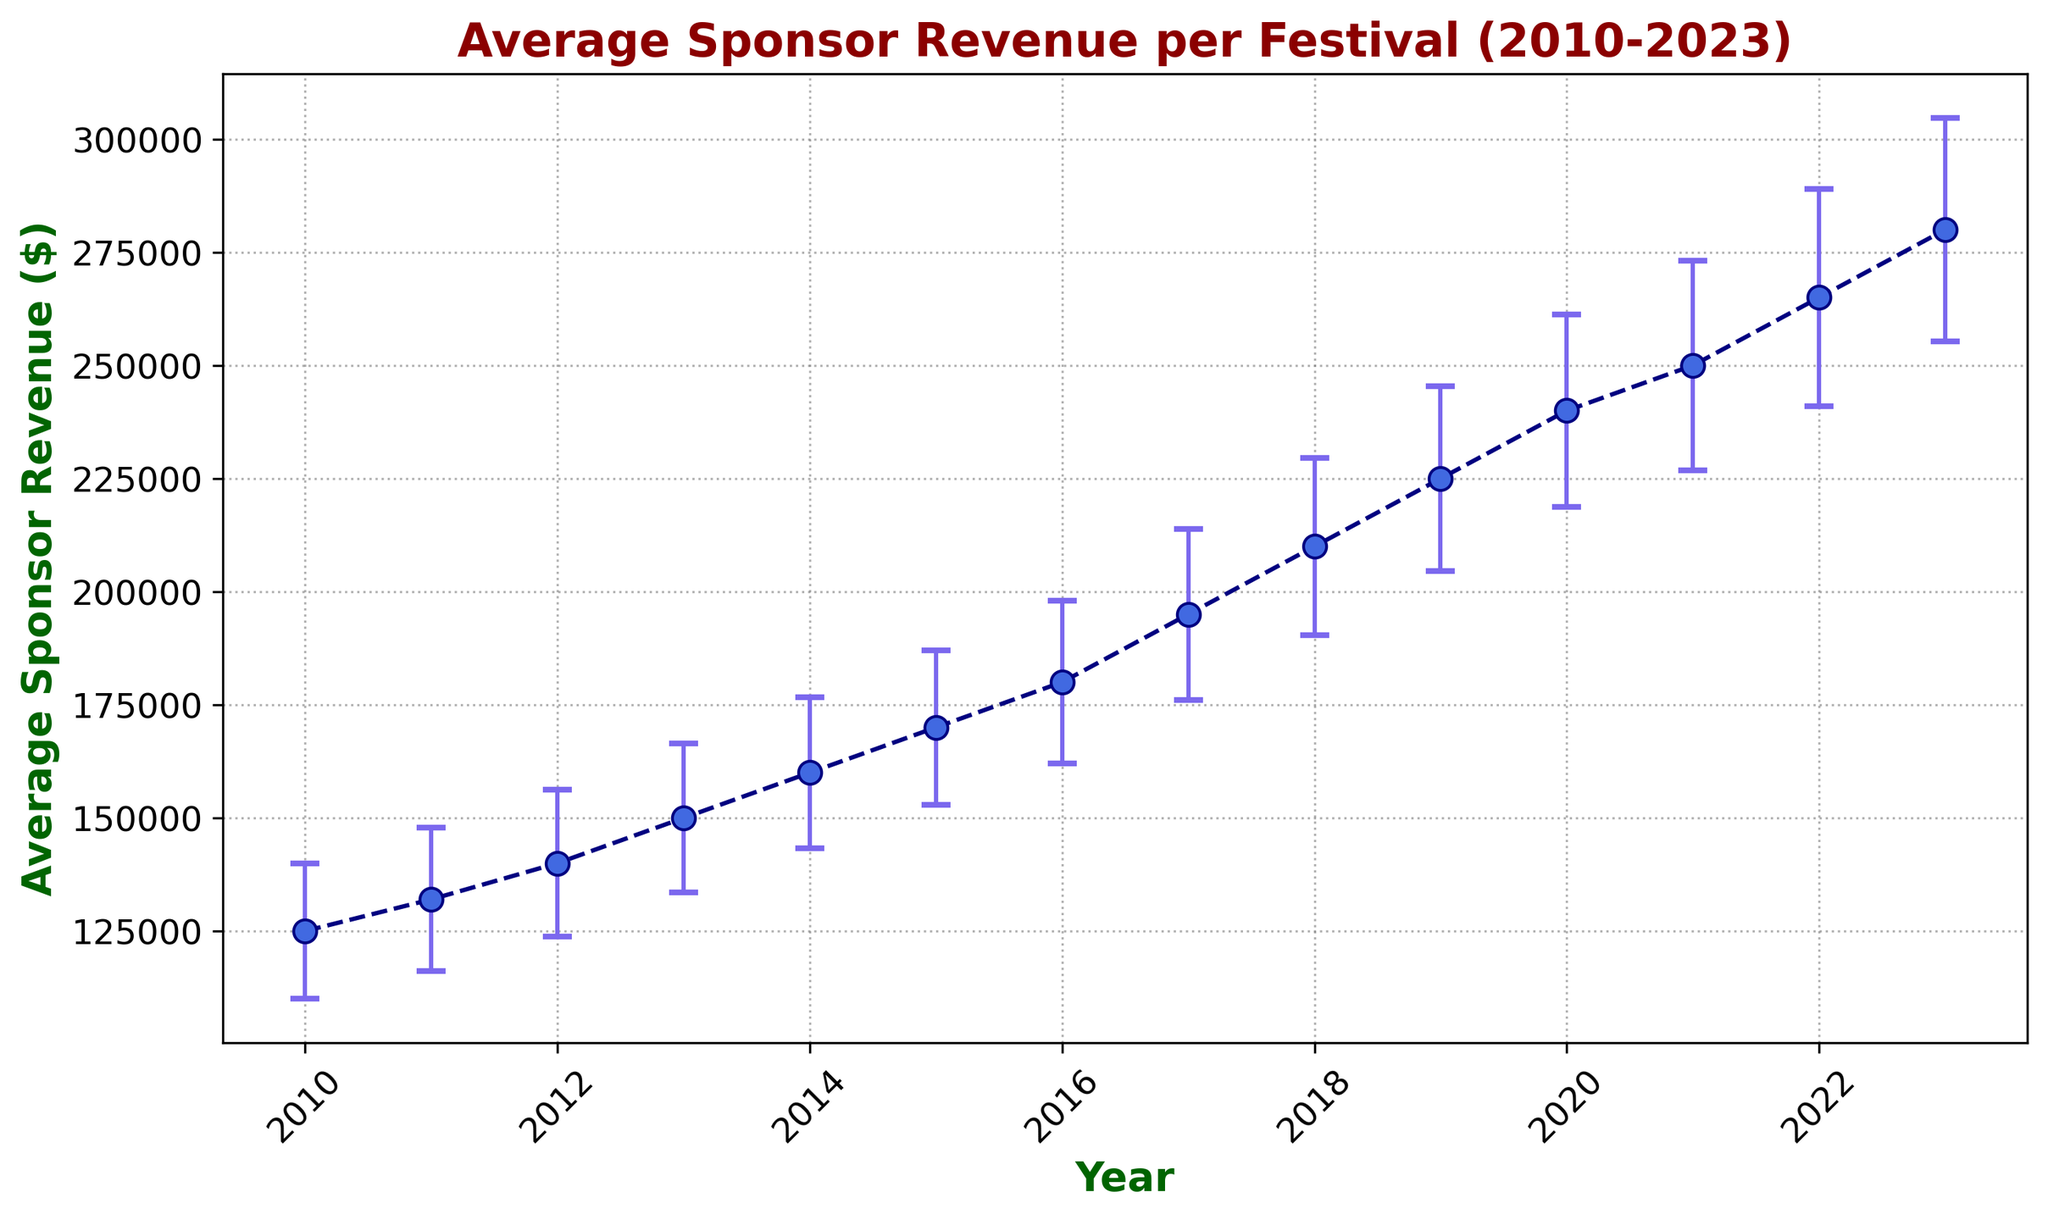What's the highest average sponsor revenue recorded? Look at the highest point on the graph. The highest average sponsor revenue is recorded in 2023.
Answer: $280,000 Which year had the smallest historical variance? Locate the points marking historical variance along the y-axis and determine which is the smallest. The smallest historical variance occurs in 2010.
Answer: $12,000 What is the general trend for average sponsor revenue over the years? Observe the direction and pattern of the data points over time. The general trend shows a steady increase in average sponsor revenue from 2010 to 2023.
Answer: Increasing How does the projection accuracy change from 2010 to 2023? Examine the values of projection accuracy across the years. The projection accuracy increases over the years from 0.8 in 2010 to 0.97 in 2023.
Answer: Increases In which year did the average sponsor revenue first reach or exceed $200,000? Identify the year when the data points first cross the $200,000 mark on the y-axis. The first year the average sponsor revenue reached or exceeded $200,000 was in 2018.
Answer: 2018 What's the difference in average sponsor revenue between 2015 and 2020? Find the average sponsor revenues for 2015 and 2020, then calculate the difference: $240,000 - $170,000 = $70,000.
Answer: $70,000 Which year saw the largest increase in average sponsor revenue compared to the previous year? Calculate the year-to-year increase and identify the largest one. The largest increase is from 2019 ($225,000) to 2020 ($240,000), which is $15,000.
Answer: 2020 How does the variability captured by the error bars change from 2010 to 2023? Observe the length of the error bars over the years. The variability, as reflected by the error bars, generally increases from 2010 to 2023.
Answer: Increases Which year had the highest projection accuracy and what is the value? Identify the peak value of projection accuracy on the graph. The highest projection accuracy occurs in 2023 with a value of 0.97.
Answer: 2023, 0.97 How does the historical variance for 2018 compare to that of 2021? Compare the historical variances for 2018 and 2021: $18,000 (2018) and $22,000 (2021). 2018 has a lower variance than 2021 by $4,000.
Answer: 2018 has $4,000 less 